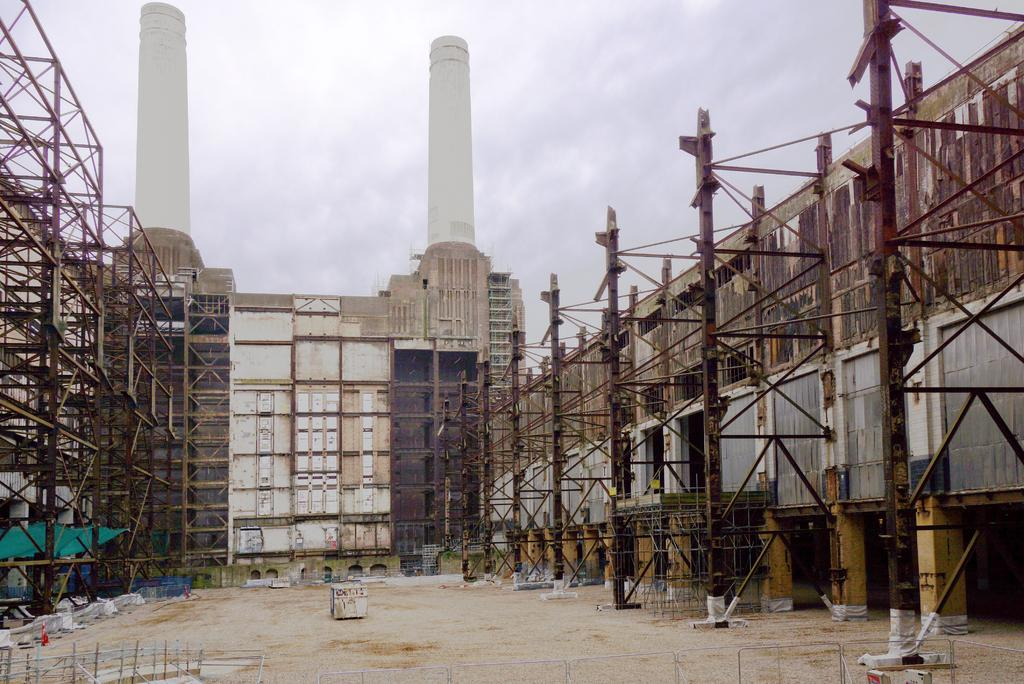What is the main structure in the center of the image? There is a building in the center of the image. What can be seen on the right side of the image? There are poles on the right side of the image. What is present on the left side of the image? There are railings on the left side of the image. What is visible in the background of the image? The sky is visible in the background of the image. What type of art can be seen on the building in the image? There is no art visible on the building in the image; it is a plain structure. 